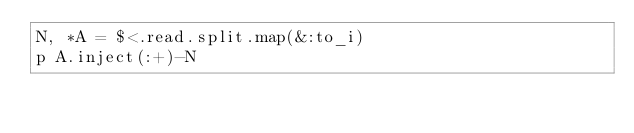Convert code to text. <code><loc_0><loc_0><loc_500><loc_500><_Ruby_>N, *A = $<.read.split.map(&:to_i)
p A.inject(:+)-N
</code> 